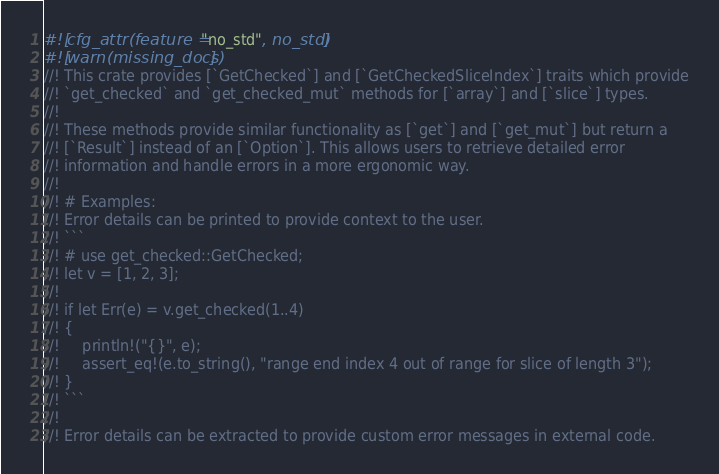<code> <loc_0><loc_0><loc_500><loc_500><_Rust_>#![cfg_attr(feature = "no_std", no_std)]
#![warn(missing_docs)]
//! This crate provides [`GetChecked`] and [`GetCheckedSliceIndex`] traits which provide
//! `get_checked` and `get_checked_mut` methods for [`array`] and [`slice`] types.
//!
//! These methods provide similar functionality as [`get`] and [`get_mut`] but return a
//! [`Result`] instead of an [`Option`]. This allows users to retrieve detailed error
//! information and handle errors in a more ergonomic way.
//!
//! # Examples:
//! Error details can be printed to provide context to the user.
//! ```
//! # use get_checked::GetChecked;
//! let v = [1, 2, 3];
//!
//! if let Err(e) = v.get_checked(1..4)
//! {
//!     println!("{}", e);
//!     assert_eq!(e.to_string(), "range end index 4 out of range for slice of length 3");
//! }
//! ```
//!
//! Error details can be extracted to provide custom error messages in external code.</code> 